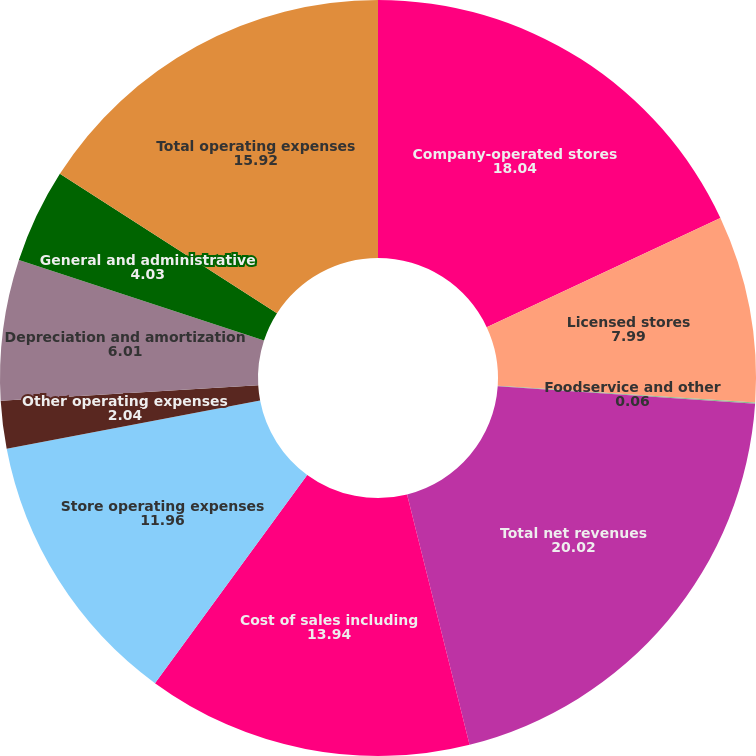<chart> <loc_0><loc_0><loc_500><loc_500><pie_chart><fcel>Company-operated stores<fcel>Licensed stores<fcel>Foodservice and other<fcel>Total net revenues<fcel>Cost of sales including<fcel>Store operating expenses<fcel>Other operating expenses<fcel>Depreciation and amortization<fcel>General and administrative<fcel>Total operating expenses<nl><fcel>18.04%<fcel>7.99%<fcel>0.06%<fcel>20.02%<fcel>13.94%<fcel>11.96%<fcel>2.04%<fcel>6.01%<fcel>4.03%<fcel>15.92%<nl></chart> 